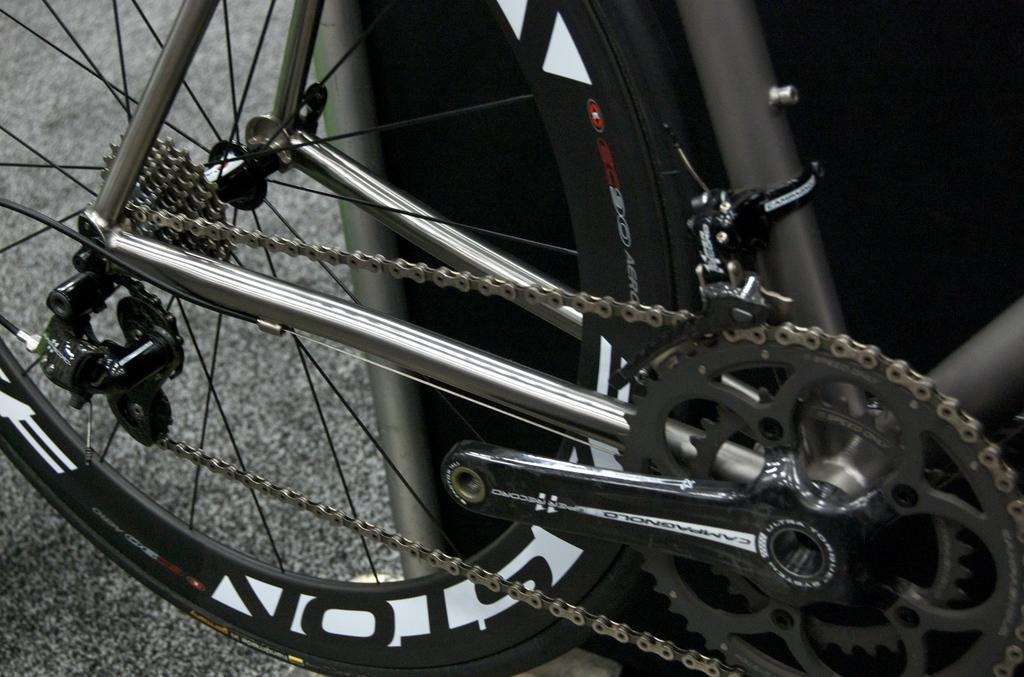What is the main subject of the image? The main subject of the image is a bicycle. What is the color of the object mentioned in the image? There is a black color object in the image. Where are the bicycle and the black color object located? The bicycle and the black color object are on the road. Can you tell me how many times the bicycle has been bitten by the stone in the image? There is no stone present in the image, and therefore no such activity can be observed. 